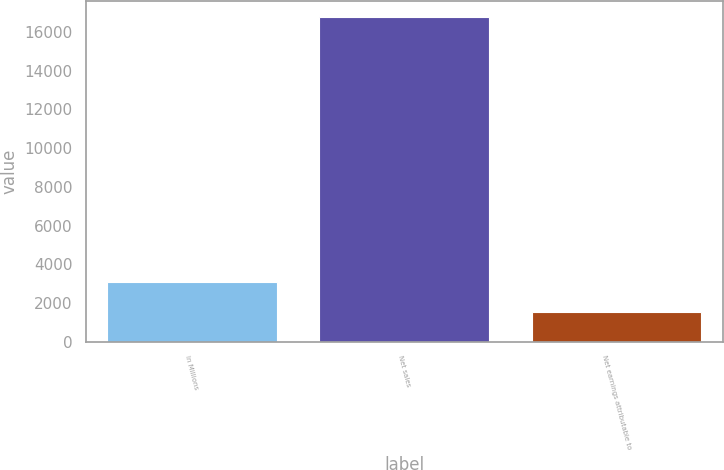<chart> <loc_0><loc_0><loc_500><loc_500><bar_chart><fcel>In Millions<fcel>Net sales<fcel>Net earnings attributable to<nl><fcel>3063.47<fcel>16772.9<fcel>1540.2<nl></chart> 